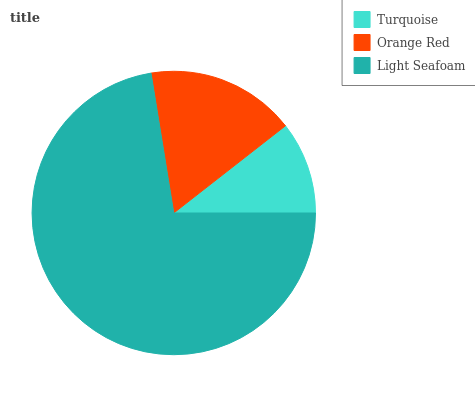Is Turquoise the minimum?
Answer yes or no. Yes. Is Light Seafoam the maximum?
Answer yes or no. Yes. Is Orange Red the minimum?
Answer yes or no. No. Is Orange Red the maximum?
Answer yes or no. No. Is Orange Red greater than Turquoise?
Answer yes or no. Yes. Is Turquoise less than Orange Red?
Answer yes or no. Yes. Is Turquoise greater than Orange Red?
Answer yes or no. No. Is Orange Red less than Turquoise?
Answer yes or no. No. Is Orange Red the high median?
Answer yes or no. Yes. Is Orange Red the low median?
Answer yes or no. Yes. Is Light Seafoam the high median?
Answer yes or no. No. Is Light Seafoam the low median?
Answer yes or no. No. 